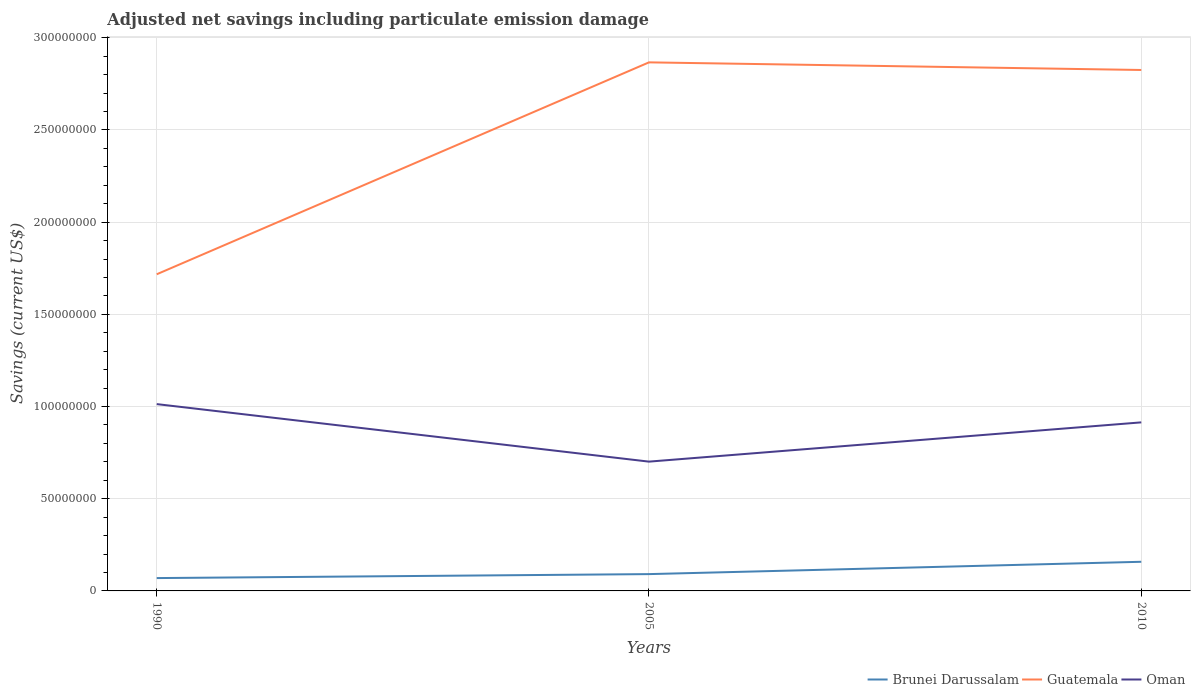How many different coloured lines are there?
Provide a short and direct response. 3. Does the line corresponding to Guatemala intersect with the line corresponding to Brunei Darussalam?
Offer a terse response. No. Is the number of lines equal to the number of legend labels?
Keep it short and to the point. Yes. Across all years, what is the maximum net savings in Brunei Darussalam?
Give a very brief answer. 6.97e+06. In which year was the net savings in Guatemala maximum?
Give a very brief answer. 1990. What is the total net savings in Oman in the graph?
Offer a terse response. 3.12e+07. What is the difference between the highest and the second highest net savings in Brunei Darussalam?
Your answer should be compact. 8.83e+06. What is the difference between the highest and the lowest net savings in Brunei Darussalam?
Make the answer very short. 1. Is the net savings in Brunei Darussalam strictly greater than the net savings in Oman over the years?
Give a very brief answer. Yes. How many lines are there?
Ensure brevity in your answer.  3. Are the values on the major ticks of Y-axis written in scientific E-notation?
Offer a very short reply. No. Does the graph contain grids?
Provide a short and direct response. Yes. How many legend labels are there?
Provide a short and direct response. 3. What is the title of the graph?
Provide a succinct answer. Adjusted net savings including particulate emission damage. What is the label or title of the X-axis?
Give a very brief answer. Years. What is the label or title of the Y-axis?
Offer a terse response. Savings (current US$). What is the Savings (current US$) of Brunei Darussalam in 1990?
Keep it short and to the point. 6.97e+06. What is the Savings (current US$) in Guatemala in 1990?
Ensure brevity in your answer.  1.72e+08. What is the Savings (current US$) in Oman in 1990?
Your answer should be very brief. 1.01e+08. What is the Savings (current US$) in Brunei Darussalam in 2005?
Make the answer very short. 9.12e+06. What is the Savings (current US$) in Guatemala in 2005?
Make the answer very short. 2.87e+08. What is the Savings (current US$) in Oman in 2005?
Keep it short and to the point. 7.01e+07. What is the Savings (current US$) in Brunei Darussalam in 2010?
Give a very brief answer. 1.58e+07. What is the Savings (current US$) of Guatemala in 2010?
Keep it short and to the point. 2.83e+08. What is the Savings (current US$) of Oman in 2010?
Your answer should be compact. 9.14e+07. Across all years, what is the maximum Savings (current US$) in Brunei Darussalam?
Keep it short and to the point. 1.58e+07. Across all years, what is the maximum Savings (current US$) of Guatemala?
Make the answer very short. 2.87e+08. Across all years, what is the maximum Savings (current US$) in Oman?
Offer a very short reply. 1.01e+08. Across all years, what is the minimum Savings (current US$) of Brunei Darussalam?
Offer a terse response. 6.97e+06. Across all years, what is the minimum Savings (current US$) of Guatemala?
Your answer should be compact. 1.72e+08. Across all years, what is the minimum Savings (current US$) in Oman?
Make the answer very short. 7.01e+07. What is the total Savings (current US$) in Brunei Darussalam in the graph?
Offer a terse response. 3.19e+07. What is the total Savings (current US$) of Guatemala in the graph?
Your response must be concise. 7.41e+08. What is the total Savings (current US$) of Oman in the graph?
Offer a very short reply. 2.63e+08. What is the difference between the Savings (current US$) of Brunei Darussalam in 1990 and that in 2005?
Provide a short and direct response. -2.15e+06. What is the difference between the Savings (current US$) of Guatemala in 1990 and that in 2005?
Your answer should be compact. -1.15e+08. What is the difference between the Savings (current US$) of Oman in 1990 and that in 2005?
Offer a very short reply. 3.12e+07. What is the difference between the Savings (current US$) in Brunei Darussalam in 1990 and that in 2010?
Offer a terse response. -8.83e+06. What is the difference between the Savings (current US$) in Guatemala in 1990 and that in 2010?
Give a very brief answer. -1.11e+08. What is the difference between the Savings (current US$) of Oman in 1990 and that in 2010?
Provide a succinct answer. 9.91e+06. What is the difference between the Savings (current US$) in Brunei Darussalam in 2005 and that in 2010?
Offer a terse response. -6.68e+06. What is the difference between the Savings (current US$) of Guatemala in 2005 and that in 2010?
Offer a very short reply. 4.13e+06. What is the difference between the Savings (current US$) in Oman in 2005 and that in 2010?
Offer a very short reply. -2.13e+07. What is the difference between the Savings (current US$) of Brunei Darussalam in 1990 and the Savings (current US$) of Guatemala in 2005?
Keep it short and to the point. -2.80e+08. What is the difference between the Savings (current US$) in Brunei Darussalam in 1990 and the Savings (current US$) in Oman in 2005?
Keep it short and to the point. -6.31e+07. What is the difference between the Savings (current US$) in Guatemala in 1990 and the Savings (current US$) in Oman in 2005?
Your answer should be compact. 1.02e+08. What is the difference between the Savings (current US$) in Brunei Darussalam in 1990 and the Savings (current US$) in Guatemala in 2010?
Offer a very short reply. -2.76e+08. What is the difference between the Savings (current US$) of Brunei Darussalam in 1990 and the Savings (current US$) of Oman in 2010?
Keep it short and to the point. -8.44e+07. What is the difference between the Savings (current US$) of Guatemala in 1990 and the Savings (current US$) of Oman in 2010?
Provide a succinct answer. 8.03e+07. What is the difference between the Savings (current US$) in Brunei Darussalam in 2005 and the Savings (current US$) in Guatemala in 2010?
Your answer should be compact. -2.73e+08. What is the difference between the Savings (current US$) of Brunei Darussalam in 2005 and the Savings (current US$) of Oman in 2010?
Give a very brief answer. -8.23e+07. What is the difference between the Savings (current US$) in Guatemala in 2005 and the Savings (current US$) in Oman in 2010?
Your response must be concise. 1.95e+08. What is the average Savings (current US$) of Brunei Darussalam per year?
Give a very brief answer. 1.06e+07. What is the average Savings (current US$) of Guatemala per year?
Make the answer very short. 2.47e+08. What is the average Savings (current US$) of Oman per year?
Offer a very short reply. 8.76e+07. In the year 1990, what is the difference between the Savings (current US$) in Brunei Darussalam and Savings (current US$) in Guatemala?
Offer a terse response. -1.65e+08. In the year 1990, what is the difference between the Savings (current US$) of Brunei Darussalam and Savings (current US$) of Oman?
Make the answer very short. -9.43e+07. In the year 1990, what is the difference between the Savings (current US$) in Guatemala and Savings (current US$) in Oman?
Make the answer very short. 7.04e+07. In the year 2005, what is the difference between the Savings (current US$) in Brunei Darussalam and Savings (current US$) in Guatemala?
Keep it short and to the point. -2.78e+08. In the year 2005, what is the difference between the Savings (current US$) of Brunei Darussalam and Savings (current US$) of Oman?
Provide a succinct answer. -6.10e+07. In the year 2005, what is the difference between the Savings (current US$) of Guatemala and Savings (current US$) of Oman?
Your response must be concise. 2.17e+08. In the year 2010, what is the difference between the Savings (current US$) in Brunei Darussalam and Savings (current US$) in Guatemala?
Provide a succinct answer. -2.67e+08. In the year 2010, what is the difference between the Savings (current US$) in Brunei Darussalam and Savings (current US$) in Oman?
Provide a succinct answer. -7.56e+07. In the year 2010, what is the difference between the Savings (current US$) of Guatemala and Savings (current US$) of Oman?
Provide a succinct answer. 1.91e+08. What is the ratio of the Savings (current US$) in Brunei Darussalam in 1990 to that in 2005?
Give a very brief answer. 0.76. What is the ratio of the Savings (current US$) in Guatemala in 1990 to that in 2005?
Provide a short and direct response. 0.6. What is the ratio of the Savings (current US$) in Oman in 1990 to that in 2005?
Offer a terse response. 1.44. What is the ratio of the Savings (current US$) in Brunei Darussalam in 1990 to that in 2010?
Provide a short and direct response. 0.44. What is the ratio of the Savings (current US$) of Guatemala in 1990 to that in 2010?
Keep it short and to the point. 0.61. What is the ratio of the Savings (current US$) of Oman in 1990 to that in 2010?
Your answer should be compact. 1.11. What is the ratio of the Savings (current US$) of Brunei Darussalam in 2005 to that in 2010?
Provide a short and direct response. 0.58. What is the ratio of the Savings (current US$) of Guatemala in 2005 to that in 2010?
Offer a terse response. 1.01. What is the ratio of the Savings (current US$) in Oman in 2005 to that in 2010?
Offer a very short reply. 0.77. What is the difference between the highest and the second highest Savings (current US$) in Brunei Darussalam?
Ensure brevity in your answer.  6.68e+06. What is the difference between the highest and the second highest Savings (current US$) of Guatemala?
Offer a terse response. 4.13e+06. What is the difference between the highest and the second highest Savings (current US$) of Oman?
Your answer should be compact. 9.91e+06. What is the difference between the highest and the lowest Savings (current US$) of Brunei Darussalam?
Provide a short and direct response. 8.83e+06. What is the difference between the highest and the lowest Savings (current US$) of Guatemala?
Your answer should be very brief. 1.15e+08. What is the difference between the highest and the lowest Savings (current US$) in Oman?
Provide a short and direct response. 3.12e+07. 